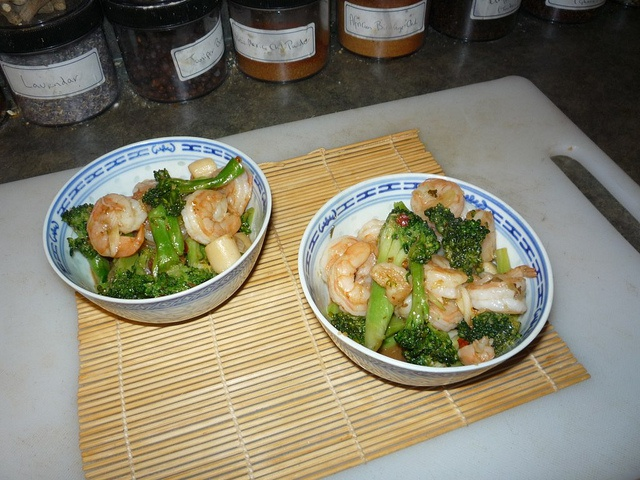Describe the objects in this image and their specific colors. I can see bowl in maroon, tan, lightgray, olive, and black tones, bowl in maroon, darkgreen, tan, darkgray, and lightgray tones, bottle in maroon, black, darkgray, and gray tones, bottle in maroon, black, darkgray, and gray tones, and bottle in maroon, black, darkgray, and gray tones in this image. 